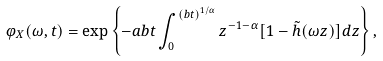Convert formula to latex. <formula><loc_0><loc_0><loc_500><loc_500>\varphi _ { X } ( \omega , t ) = \exp \left \{ - a b t \int _ { 0 } ^ { ( b t ) ^ { 1 / \alpha } } z ^ { - 1 - \alpha } [ 1 - \tilde { h } ( \omega z ) ] d z \right \} ,</formula> 